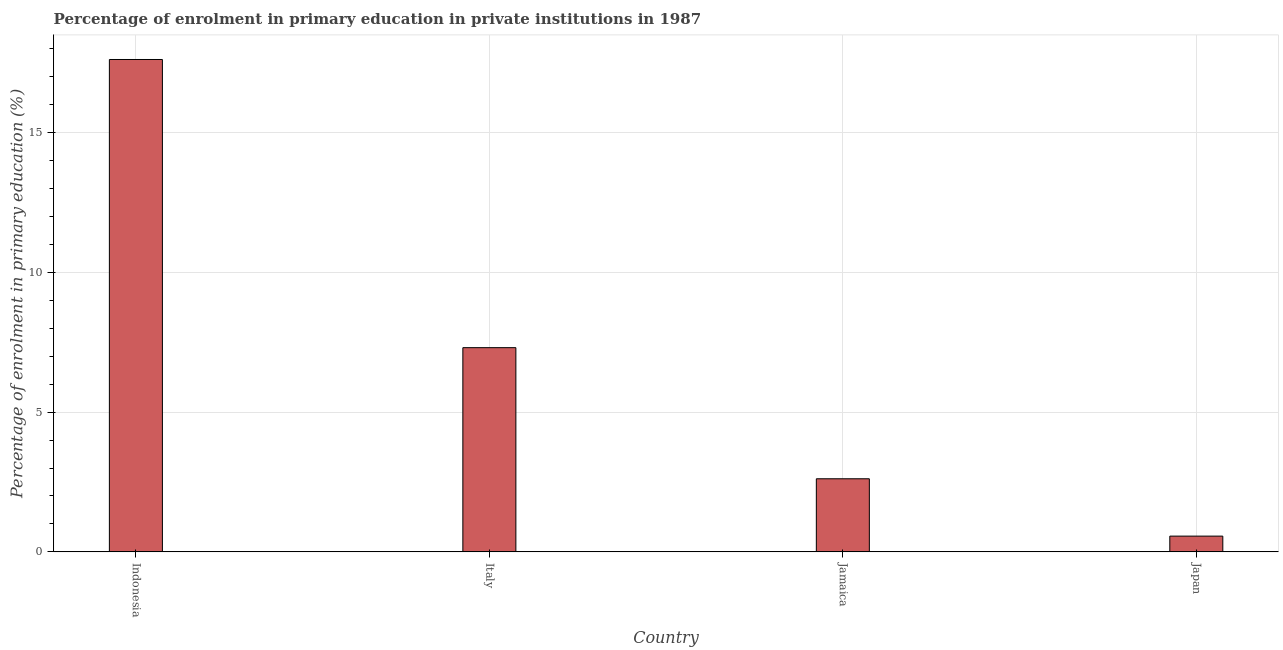Does the graph contain grids?
Your answer should be very brief. Yes. What is the title of the graph?
Give a very brief answer. Percentage of enrolment in primary education in private institutions in 1987. What is the label or title of the X-axis?
Your response must be concise. Country. What is the label or title of the Y-axis?
Ensure brevity in your answer.  Percentage of enrolment in primary education (%). What is the enrolment percentage in primary education in Japan?
Offer a terse response. 0.56. Across all countries, what is the maximum enrolment percentage in primary education?
Your answer should be compact. 17.62. Across all countries, what is the minimum enrolment percentage in primary education?
Make the answer very short. 0.56. In which country was the enrolment percentage in primary education maximum?
Provide a short and direct response. Indonesia. What is the sum of the enrolment percentage in primary education?
Provide a short and direct response. 28.1. What is the difference between the enrolment percentage in primary education in Italy and Japan?
Provide a short and direct response. 6.74. What is the average enrolment percentage in primary education per country?
Give a very brief answer. 7.03. What is the median enrolment percentage in primary education?
Provide a short and direct response. 4.96. In how many countries, is the enrolment percentage in primary education greater than 15 %?
Keep it short and to the point. 1. What is the ratio of the enrolment percentage in primary education in Indonesia to that in Jamaica?
Your answer should be compact. 6.74. Is the enrolment percentage in primary education in Italy less than that in Jamaica?
Your response must be concise. No. Is the difference between the enrolment percentage in primary education in Indonesia and Jamaica greater than the difference between any two countries?
Ensure brevity in your answer.  No. What is the difference between the highest and the second highest enrolment percentage in primary education?
Your answer should be very brief. 10.31. Is the sum of the enrolment percentage in primary education in Indonesia and Jamaica greater than the maximum enrolment percentage in primary education across all countries?
Your answer should be very brief. Yes. What is the difference between the highest and the lowest enrolment percentage in primary education?
Your answer should be compact. 17.05. What is the difference between two consecutive major ticks on the Y-axis?
Ensure brevity in your answer.  5. Are the values on the major ticks of Y-axis written in scientific E-notation?
Offer a very short reply. No. What is the Percentage of enrolment in primary education (%) of Indonesia?
Your answer should be compact. 17.62. What is the Percentage of enrolment in primary education (%) in Italy?
Your response must be concise. 7.31. What is the Percentage of enrolment in primary education (%) in Jamaica?
Provide a succinct answer. 2.62. What is the Percentage of enrolment in primary education (%) of Japan?
Provide a short and direct response. 0.56. What is the difference between the Percentage of enrolment in primary education (%) in Indonesia and Italy?
Make the answer very short. 10.31. What is the difference between the Percentage of enrolment in primary education (%) in Indonesia and Jamaica?
Your answer should be very brief. 15. What is the difference between the Percentage of enrolment in primary education (%) in Indonesia and Japan?
Provide a short and direct response. 17.05. What is the difference between the Percentage of enrolment in primary education (%) in Italy and Jamaica?
Your answer should be very brief. 4.69. What is the difference between the Percentage of enrolment in primary education (%) in Italy and Japan?
Offer a terse response. 6.74. What is the difference between the Percentage of enrolment in primary education (%) in Jamaica and Japan?
Ensure brevity in your answer.  2.05. What is the ratio of the Percentage of enrolment in primary education (%) in Indonesia to that in Italy?
Your answer should be compact. 2.41. What is the ratio of the Percentage of enrolment in primary education (%) in Indonesia to that in Jamaica?
Keep it short and to the point. 6.74. What is the ratio of the Percentage of enrolment in primary education (%) in Indonesia to that in Japan?
Provide a short and direct response. 31.24. What is the ratio of the Percentage of enrolment in primary education (%) in Italy to that in Jamaica?
Offer a terse response. 2.79. What is the ratio of the Percentage of enrolment in primary education (%) in Italy to that in Japan?
Give a very brief answer. 12.96. What is the ratio of the Percentage of enrolment in primary education (%) in Jamaica to that in Japan?
Your answer should be compact. 4.64. 